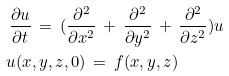<formula> <loc_0><loc_0><loc_500><loc_500>\frac { \partial u } { \partial t } & \, = \, ( \frac { \partial ^ { 2 } } { \partial x ^ { 2 } } \, + \, \frac { \partial ^ { 2 } } { \partial y ^ { 2 } } \, + \, \frac { \partial ^ { 2 } } { \partial z ^ { 2 } } ) u \\ u ( x & , y , z , 0 ) \, = \, f ( x , y , z )</formula> 